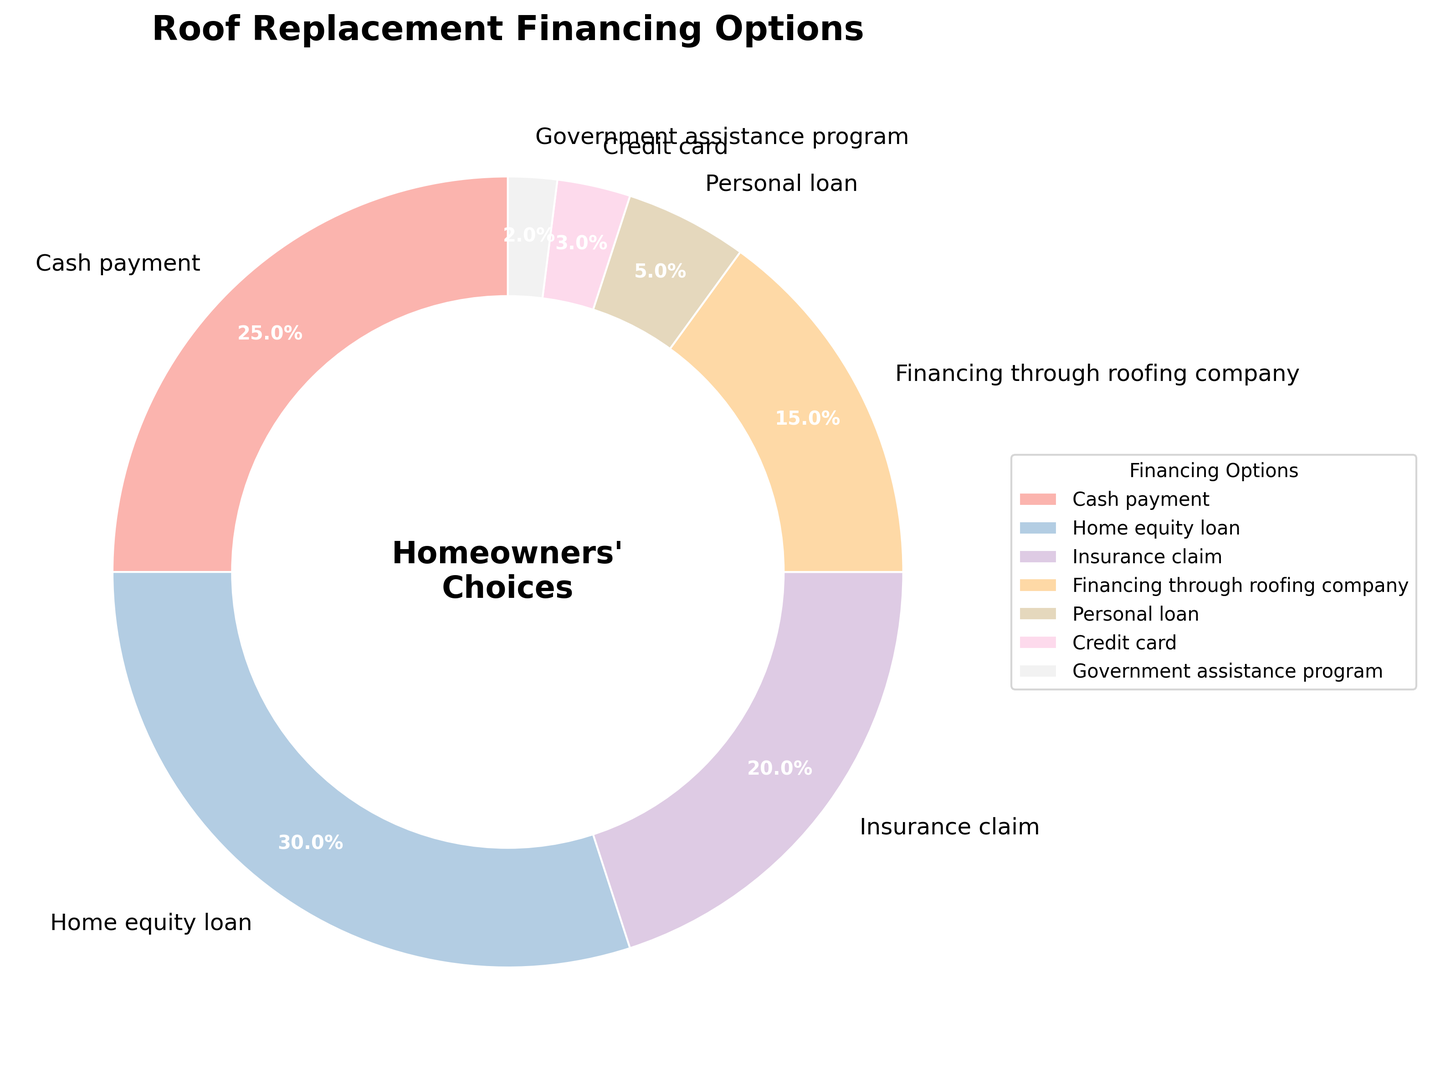What's the largest proportion of homeowners who opted for a specific financing option? First, identify the option with the highest percentage. The highest value in the pie chart is "Home equity loan" with 30%.
Answer: 30% Which financing option was chosen by the smallest percentage of homeowners? Review the percentages to find the lowest one. "Government assistance program" is the smallest with 2%.
Answer: 2% What's the combined percentage for cash payment and insurance claim options? Add the percentages for "Cash payment" (25%) and "Insurance claim" (20%). The combined percentage is 25% + 20% = 45%.
Answer: 45% Are there more homeowners choosing an insurance claim compared to those choosing a personal loan? Compare the percentages for "Insurance claim" (20%) and "Personal loan" (5%). Since 20% is greater than 5%, more homeowners chose an insurance claim.
Answer: Yes Which financing options have a percentage greater than 10%? Identify the options with percentages more than 10%. These are "Cash payment" (25%), "Home equity loan" (30%), "Insurance claim" (20%), and "Financing through roofing company" (15%).
Answer: Cash payment, Home equity loan, Insurance claim, Financing through roofing company How much more popular is using cash payment compared to using a credit card? Subtract the percentage for "Credit card" (3%) from "Cash payment" (25%). The difference is 25% - 3% = 22%.
Answer: 22% What percentage of homeowners used either a personal loan or a credit card to finance their roof replacement? Add the percentages for "Personal loan" (5%) and "Credit card" (3%). The total is 5% + 3% = 8%.
Answer: 8% If you combine the financing options chosen by fewer than 5% of homeowners, what is the total percentage? Sum the percentages for "Personal loan" (5%), "Credit card" (3%), and "Government assistance program" (2%). The total is 5% + 3% + 2% = 10%.
Answer: 10% Is the percentage of homeowners using financing through a roofing company closer to the percentage of those using an insurance claim or a home equity loan? Compare the percentage for "Financing through roofing company" (15%) with the percentages for "Insurance claim" (20%) and "Home equity loan" (30%). Since 15% is closer to 20% than 30%, it's closer to "Insurance claim".
Answer: Insurance claim Which two financing options together make up exactly half of the homeowners' choices? Find two options whose combined percentages total 50%. "Home equity loan" (30%) and "Insurance claim" (20%) together make up 30% + 20% = 50%.
Answer: Home equity loan, Insurance claim 